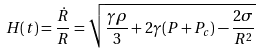<formula> <loc_0><loc_0><loc_500><loc_500>H ( t ) = \frac { \dot { R } } R = \sqrt { { \frac { \gamma \rho } 3 } + 2 \gamma ( P + P _ { c } ) - \frac { 2 \sigma } { R ^ { 2 } } }</formula> 